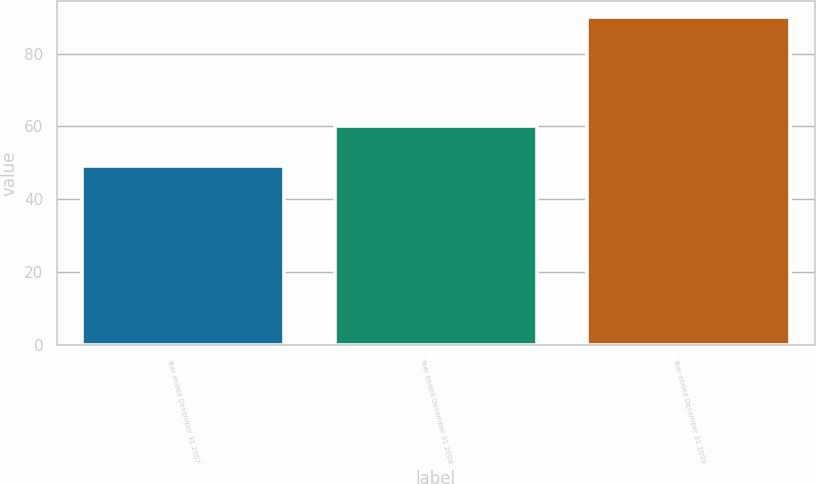Convert chart. <chart><loc_0><loc_0><loc_500><loc_500><bar_chart><fcel>Year ended December 31 2007<fcel>Year ended December 31 2008<fcel>Year ended December 31 2009<nl><fcel>49<fcel>60<fcel>90<nl></chart> 